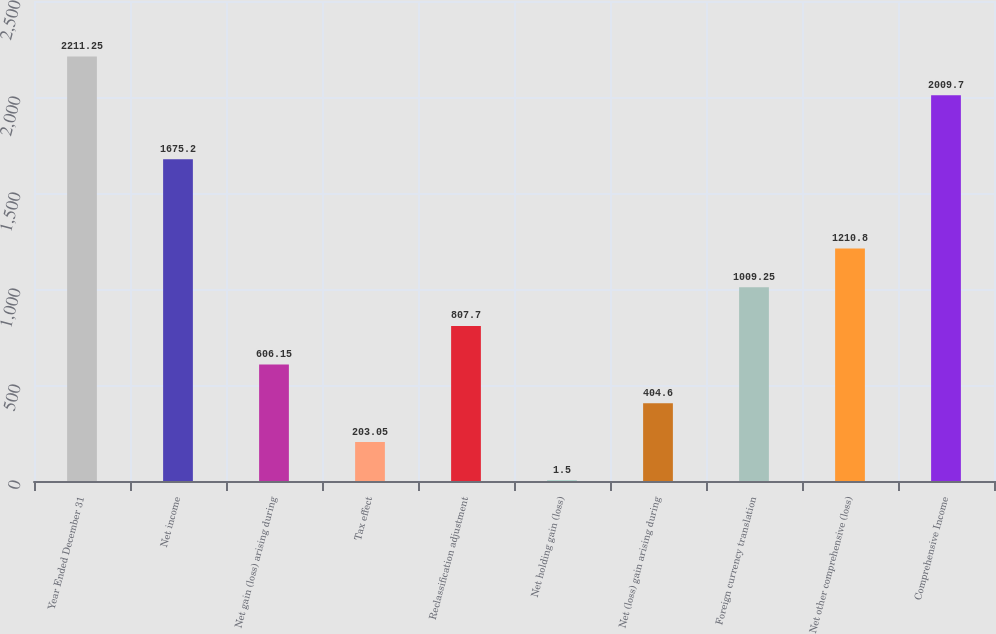Convert chart to OTSL. <chart><loc_0><loc_0><loc_500><loc_500><bar_chart><fcel>Year Ended December 31<fcel>Net income<fcel>Net gain (loss) arising during<fcel>Tax effect<fcel>Reclassification adjustment<fcel>Net holding gain (loss)<fcel>Net (loss) gain arising during<fcel>Foreign currency translation<fcel>Net other comprehensive (loss)<fcel>Comprehensive Income<nl><fcel>2211.25<fcel>1675.2<fcel>606.15<fcel>203.05<fcel>807.7<fcel>1.5<fcel>404.6<fcel>1009.25<fcel>1210.8<fcel>2009.7<nl></chart> 